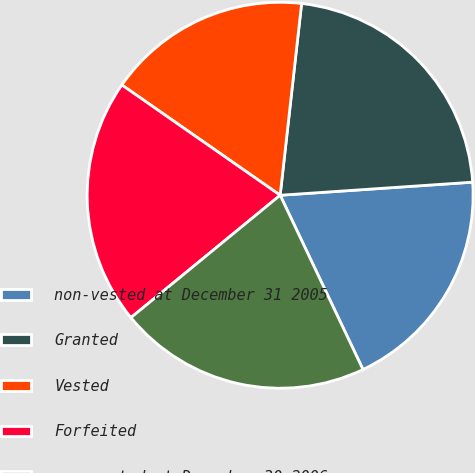<chart> <loc_0><loc_0><loc_500><loc_500><pie_chart><fcel>non-vested at December 31 2005<fcel>Granted<fcel>Vested<fcel>Forfeited<fcel>non-vested at December 30 2006<nl><fcel>19.02%<fcel>22.15%<fcel>17.09%<fcel>20.62%<fcel>21.13%<nl></chart> 